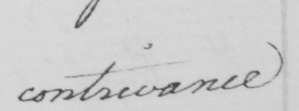What does this handwritten line say? contrivance 